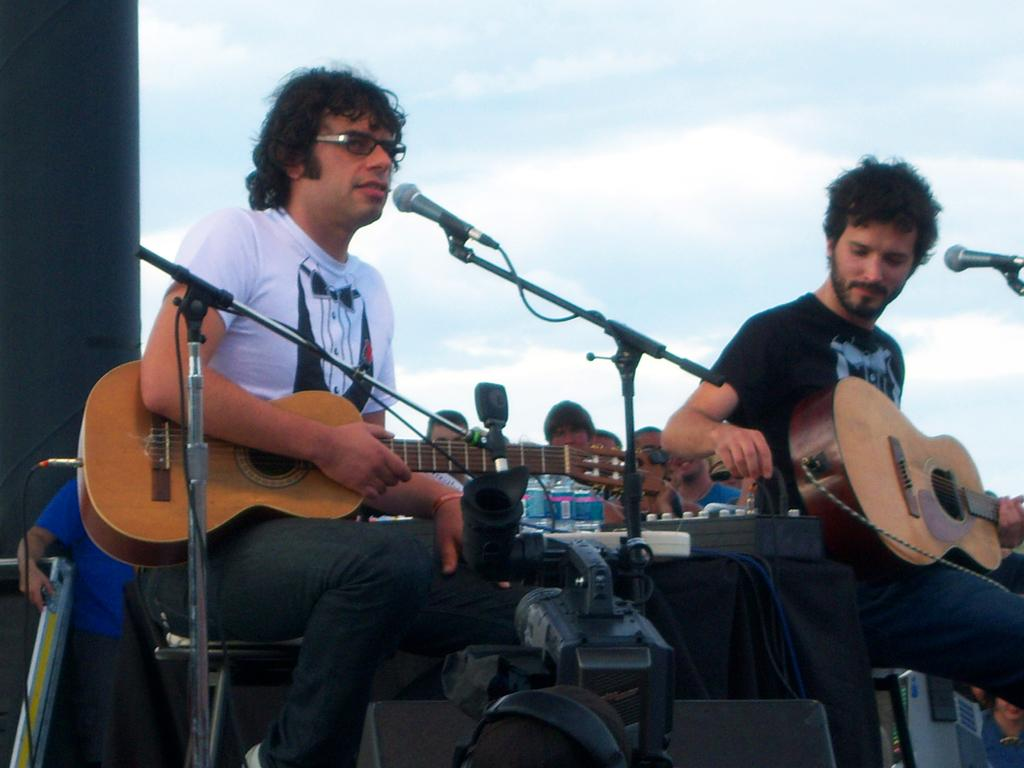How many people are in the image? There are two persons in the image. What are the two persons doing? The two persons are playing guitar. What objects are in the foreground of the image? There are microphones in the foreground of the image. Can you describe the background of the image? There are persons sitting in the background of the image. What type of cakes are being served to the audience in the image? There are no cakes or audience present in the image; it features two persons playing guitar and microphones in the foreground. What thought is going through the mind of the person playing the guitar in the image? We cannot determine the thoughts of the person playing the guitar in the image based on the visual information provided. 